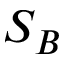<formula> <loc_0><loc_0><loc_500><loc_500>S _ { B }</formula> 